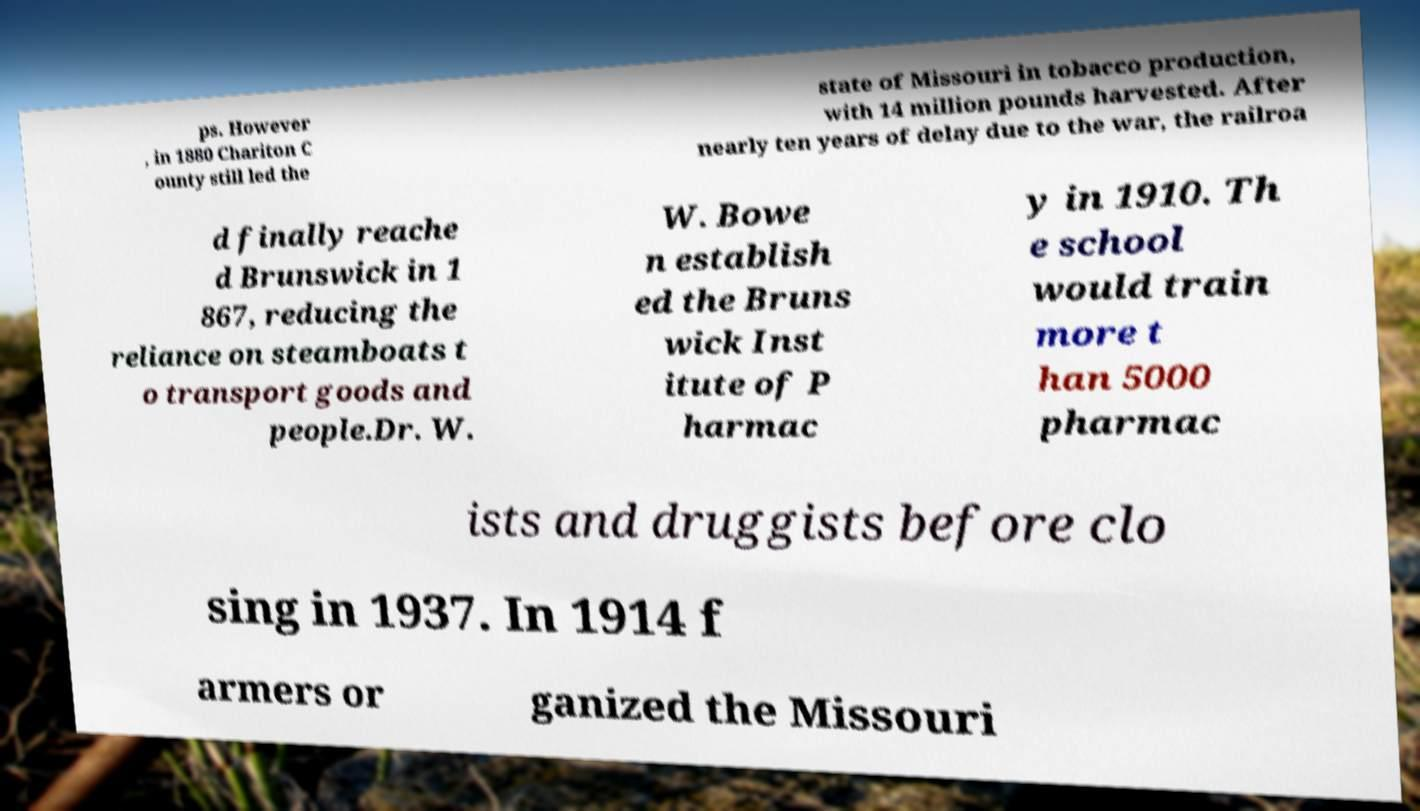What messages or text are displayed in this image? I need them in a readable, typed format. ps. However , in 1880 Chariton C ounty still led the state of Missouri in tobacco production, with 14 million pounds harvested. After nearly ten years of delay due to the war, the railroa d finally reache d Brunswick in 1 867, reducing the reliance on steamboats t o transport goods and people.Dr. W. W. Bowe n establish ed the Bruns wick Inst itute of P harmac y in 1910. Th e school would train more t han 5000 pharmac ists and druggists before clo sing in 1937. In 1914 f armers or ganized the Missouri 